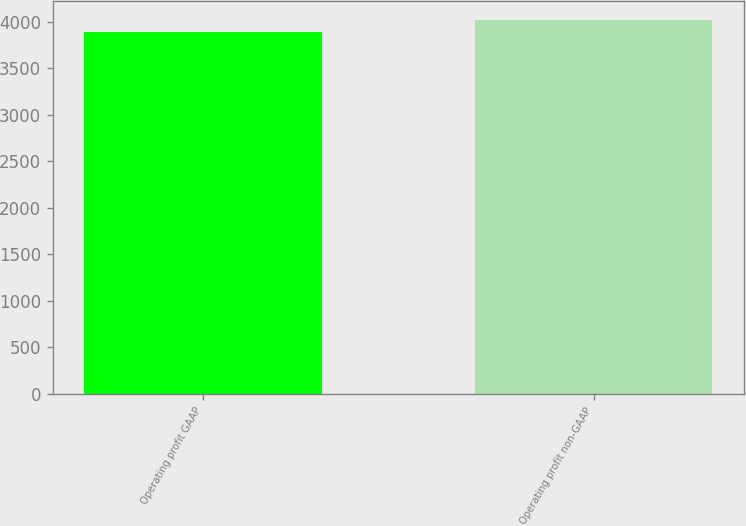Convert chart. <chart><loc_0><loc_0><loc_500><loc_500><bar_chart><fcel>Operating profit GAAP<fcel>Operating profit non-GAAP<nl><fcel>3889<fcel>4023<nl></chart> 